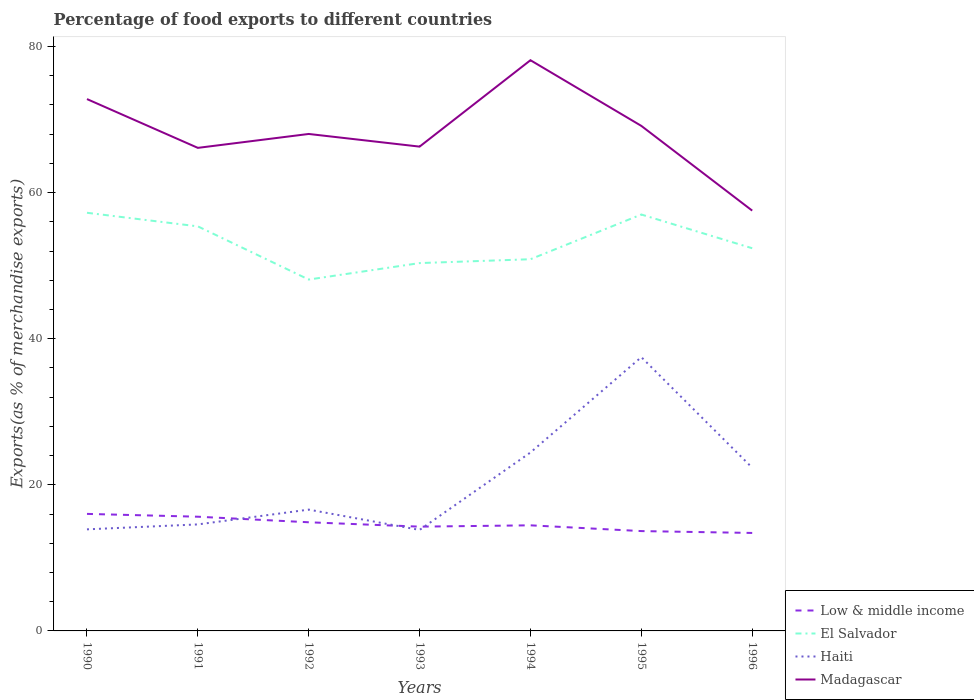How many different coloured lines are there?
Provide a succinct answer. 4. Across all years, what is the maximum percentage of exports to different countries in Madagascar?
Make the answer very short. 57.53. In which year was the percentage of exports to different countries in Haiti maximum?
Keep it short and to the point. 1993. What is the total percentage of exports to different countries in Madagascar in the graph?
Your response must be concise. 11.6. What is the difference between the highest and the second highest percentage of exports to different countries in Low & middle income?
Ensure brevity in your answer.  2.61. What is the difference between the highest and the lowest percentage of exports to different countries in Low & middle income?
Offer a very short reply. 3. Are the values on the major ticks of Y-axis written in scientific E-notation?
Give a very brief answer. No. Does the graph contain grids?
Offer a terse response. No. Where does the legend appear in the graph?
Provide a succinct answer. Bottom right. How many legend labels are there?
Ensure brevity in your answer.  4. How are the legend labels stacked?
Your answer should be very brief. Vertical. What is the title of the graph?
Provide a short and direct response. Percentage of food exports to different countries. What is the label or title of the Y-axis?
Offer a terse response. Exports(as % of merchandise exports). What is the Exports(as % of merchandise exports) of Low & middle income in 1990?
Your answer should be compact. 16.02. What is the Exports(as % of merchandise exports) of El Salvador in 1990?
Provide a succinct answer. 57.24. What is the Exports(as % of merchandise exports) in Haiti in 1990?
Keep it short and to the point. 13.9. What is the Exports(as % of merchandise exports) in Madagascar in 1990?
Keep it short and to the point. 72.8. What is the Exports(as % of merchandise exports) of Low & middle income in 1991?
Your answer should be very brief. 15.63. What is the Exports(as % of merchandise exports) in El Salvador in 1991?
Your answer should be very brief. 55.38. What is the Exports(as % of merchandise exports) in Haiti in 1991?
Ensure brevity in your answer.  14.58. What is the Exports(as % of merchandise exports) in Madagascar in 1991?
Your answer should be very brief. 66.12. What is the Exports(as % of merchandise exports) of Low & middle income in 1992?
Offer a very short reply. 14.87. What is the Exports(as % of merchandise exports) in El Salvador in 1992?
Your answer should be very brief. 48.1. What is the Exports(as % of merchandise exports) in Haiti in 1992?
Keep it short and to the point. 16.61. What is the Exports(as % of merchandise exports) in Madagascar in 1992?
Your response must be concise. 68.03. What is the Exports(as % of merchandise exports) of Low & middle income in 1993?
Offer a very short reply. 14.27. What is the Exports(as % of merchandise exports) in El Salvador in 1993?
Give a very brief answer. 50.35. What is the Exports(as % of merchandise exports) in Haiti in 1993?
Make the answer very short. 13.83. What is the Exports(as % of merchandise exports) of Madagascar in 1993?
Your answer should be compact. 66.29. What is the Exports(as % of merchandise exports) of Low & middle income in 1994?
Ensure brevity in your answer.  14.45. What is the Exports(as % of merchandise exports) in El Salvador in 1994?
Ensure brevity in your answer.  50.88. What is the Exports(as % of merchandise exports) of Haiti in 1994?
Your answer should be very brief. 24.42. What is the Exports(as % of merchandise exports) in Madagascar in 1994?
Your response must be concise. 78.12. What is the Exports(as % of merchandise exports) in Low & middle income in 1995?
Ensure brevity in your answer.  13.67. What is the Exports(as % of merchandise exports) of El Salvador in 1995?
Keep it short and to the point. 57. What is the Exports(as % of merchandise exports) in Haiti in 1995?
Make the answer very short. 37.48. What is the Exports(as % of merchandise exports) in Madagascar in 1995?
Provide a succinct answer. 69.13. What is the Exports(as % of merchandise exports) of Low & middle income in 1996?
Offer a very short reply. 13.41. What is the Exports(as % of merchandise exports) of El Salvador in 1996?
Your answer should be compact. 52.38. What is the Exports(as % of merchandise exports) in Haiti in 1996?
Provide a short and direct response. 22.34. What is the Exports(as % of merchandise exports) of Madagascar in 1996?
Give a very brief answer. 57.53. Across all years, what is the maximum Exports(as % of merchandise exports) in Low & middle income?
Give a very brief answer. 16.02. Across all years, what is the maximum Exports(as % of merchandise exports) of El Salvador?
Provide a succinct answer. 57.24. Across all years, what is the maximum Exports(as % of merchandise exports) of Haiti?
Offer a terse response. 37.48. Across all years, what is the maximum Exports(as % of merchandise exports) in Madagascar?
Ensure brevity in your answer.  78.12. Across all years, what is the minimum Exports(as % of merchandise exports) in Low & middle income?
Provide a succinct answer. 13.41. Across all years, what is the minimum Exports(as % of merchandise exports) of El Salvador?
Provide a succinct answer. 48.1. Across all years, what is the minimum Exports(as % of merchandise exports) in Haiti?
Keep it short and to the point. 13.83. Across all years, what is the minimum Exports(as % of merchandise exports) of Madagascar?
Ensure brevity in your answer.  57.53. What is the total Exports(as % of merchandise exports) in Low & middle income in the graph?
Give a very brief answer. 102.33. What is the total Exports(as % of merchandise exports) of El Salvador in the graph?
Make the answer very short. 371.32. What is the total Exports(as % of merchandise exports) in Haiti in the graph?
Your answer should be compact. 143.15. What is the total Exports(as % of merchandise exports) in Madagascar in the graph?
Ensure brevity in your answer.  478.03. What is the difference between the Exports(as % of merchandise exports) in Low & middle income in 1990 and that in 1991?
Ensure brevity in your answer.  0.39. What is the difference between the Exports(as % of merchandise exports) in El Salvador in 1990 and that in 1991?
Your answer should be compact. 1.86. What is the difference between the Exports(as % of merchandise exports) in Haiti in 1990 and that in 1991?
Keep it short and to the point. -0.68. What is the difference between the Exports(as % of merchandise exports) of Madagascar in 1990 and that in 1991?
Ensure brevity in your answer.  6.68. What is the difference between the Exports(as % of merchandise exports) in Low & middle income in 1990 and that in 1992?
Your answer should be compact. 1.15. What is the difference between the Exports(as % of merchandise exports) in El Salvador in 1990 and that in 1992?
Your answer should be very brief. 9.14. What is the difference between the Exports(as % of merchandise exports) in Haiti in 1990 and that in 1992?
Provide a short and direct response. -2.7. What is the difference between the Exports(as % of merchandise exports) in Madagascar in 1990 and that in 1992?
Offer a terse response. 4.78. What is the difference between the Exports(as % of merchandise exports) in Low & middle income in 1990 and that in 1993?
Give a very brief answer. 1.74. What is the difference between the Exports(as % of merchandise exports) in El Salvador in 1990 and that in 1993?
Your answer should be very brief. 6.89. What is the difference between the Exports(as % of merchandise exports) in Haiti in 1990 and that in 1993?
Make the answer very short. 0.08. What is the difference between the Exports(as % of merchandise exports) in Madagascar in 1990 and that in 1993?
Ensure brevity in your answer.  6.51. What is the difference between the Exports(as % of merchandise exports) in Low & middle income in 1990 and that in 1994?
Offer a very short reply. 1.56. What is the difference between the Exports(as % of merchandise exports) in El Salvador in 1990 and that in 1994?
Offer a terse response. 6.36. What is the difference between the Exports(as % of merchandise exports) of Haiti in 1990 and that in 1994?
Your answer should be very brief. -10.52. What is the difference between the Exports(as % of merchandise exports) of Madagascar in 1990 and that in 1994?
Your answer should be compact. -5.32. What is the difference between the Exports(as % of merchandise exports) in Low & middle income in 1990 and that in 1995?
Ensure brevity in your answer.  2.35. What is the difference between the Exports(as % of merchandise exports) of El Salvador in 1990 and that in 1995?
Make the answer very short. 0.24. What is the difference between the Exports(as % of merchandise exports) of Haiti in 1990 and that in 1995?
Your answer should be very brief. -23.57. What is the difference between the Exports(as % of merchandise exports) of Madagascar in 1990 and that in 1995?
Provide a succinct answer. 3.67. What is the difference between the Exports(as % of merchandise exports) in Low & middle income in 1990 and that in 1996?
Provide a short and direct response. 2.61. What is the difference between the Exports(as % of merchandise exports) of El Salvador in 1990 and that in 1996?
Make the answer very short. 4.85. What is the difference between the Exports(as % of merchandise exports) of Haiti in 1990 and that in 1996?
Provide a short and direct response. -8.43. What is the difference between the Exports(as % of merchandise exports) of Madagascar in 1990 and that in 1996?
Keep it short and to the point. 15.27. What is the difference between the Exports(as % of merchandise exports) in Low & middle income in 1991 and that in 1992?
Your answer should be compact. 0.76. What is the difference between the Exports(as % of merchandise exports) in El Salvador in 1991 and that in 1992?
Keep it short and to the point. 7.28. What is the difference between the Exports(as % of merchandise exports) in Haiti in 1991 and that in 1992?
Your answer should be compact. -2.03. What is the difference between the Exports(as % of merchandise exports) in Madagascar in 1991 and that in 1992?
Provide a succinct answer. -1.9. What is the difference between the Exports(as % of merchandise exports) in Low & middle income in 1991 and that in 1993?
Your response must be concise. 1.36. What is the difference between the Exports(as % of merchandise exports) in El Salvador in 1991 and that in 1993?
Offer a terse response. 5.03. What is the difference between the Exports(as % of merchandise exports) in Haiti in 1991 and that in 1993?
Ensure brevity in your answer.  0.75. What is the difference between the Exports(as % of merchandise exports) in Madagascar in 1991 and that in 1993?
Ensure brevity in your answer.  -0.17. What is the difference between the Exports(as % of merchandise exports) in Low & middle income in 1991 and that in 1994?
Provide a short and direct response. 1.18. What is the difference between the Exports(as % of merchandise exports) in El Salvador in 1991 and that in 1994?
Your answer should be very brief. 4.5. What is the difference between the Exports(as % of merchandise exports) in Haiti in 1991 and that in 1994?
Provide a short and direct response. -9.84. What is the difference between the Exports(as % of merchandise exports) of Madagascar in 1991 and that in 1994?
Provide a succinct answer. -12. What is the difference between the Exports(as % of merchandise exports) in Low & middle income in 1991 and that in 1995?
Ensure brevity in your answer.  1.97. What is the difference between the Exports(as % of merchandise exports) of El Salvador in 1991 and that in 1995?
Make the answer very short. -1.62. What is the difference between the Exports(as % of merchandise exports) in Haiti in 1991 and that in 1995?
Ensure brevity in your answer.  -22.9. What is the difference between the Exports(as % of merchandise exports) of Madagascar in 1991 and that in 1995?
Your response must be concise. -3.01. What is the difference between the Exports(as % of merchandise exports) in Low & middle income in 1991 and that in 1996?
Offer a terse response. 2.22. What is the difference between the Exports(as % of merchandise exports) in El Salvador in 1991 and that in 1996?
Give a very brief answer. 2.99. What is the difference between the Exports(as % of merchandise exports) of Haiti in 1991 and that in 1996?
Your answer should be very brief. -7.76. What is the difference between the Exports(as % of merchandise exports) of Madagascar in 1991 and that in 1996?
Keep it short and to the point. 8.59. What is the difference between the Exports(as % of merchandise exports) of Low & middle income in 1992 and that in 1993?
Your answer should be compact. 0.6. What is the difference between the Exports(as % of merchandise exports) in El Salvador in 1992 and that in 1993?
Offer a very short reply. -2.25. What is the difference between the Exports(as % of merchandise exports) of Haiti in 1992 and that in 1993?
Offer a very short reply. 2.78. What is the difference between the Exports(as % of merchandise exports) of Madagascar in 1992 and that in 1993?
Ensure brevity in your answer.  1.73. What is the difference between the Exports(as % of merchandise exports) of Low & middle income in 1992 and that in 1994?
Provide a short and direct response. 0.42. What is the difference between the Exports(as % of merchandise exports) in El Salvador in 1992 and that in 1994?
Provide a succinct answer. -2.78. What is the difference between the Exports(as % of merchandise exports) in Haiti in 1992 and that in 1994?
Your response must be concise. -7.82. What is the difference between the Exports(as % of merchandise exports) in Madagascar in 1992 and that in 1994?
Provide a succinct answer. -10.09. What is the difference between the Exports(as % of merchandise exports) of Low & middle income in 1992 and that in 1995?
Make the answer very short. 1.21. What is the difference between the Exports(as % of merchandise exports) in El Salvador in 1992 and that in 1995?
Give a very brief answer. -8.9. What is the difference between the Exports(as % of merchandise exports) of Haiti in 1992 and that in 1995?
Ensure brevity in your answer.  -20.87. What is the difference between the Exports(as % of merchandise exports) in Madagascar in 1992 and that in 1995?
Provide a succinct answer. -1.1. What is the difference between the Exports(as % of merchandise exports) of Low & middle income in 1992 and that in 1996?
Provide a succinct answer. 1.46. What is the difference between the Exports(as % of merchandise exports) in El Salvador in 1992 and that in 1996?
Keep it short and to the point. -4.29. What is the difference between the Exports(as % of merchandise exports) of Haiti in 1992 and that in 1996?
Ensure brevity in your answer.  -5.73. What is the difference between the Exports(as % of merchandise exports) of Madagascar in 1992 and that in 1996?
Make the answer very short. 10.49. What is the difference between the Exports(as % of merchandise exports) in Low & middle income in 1993 and that in 1994?
Offer a terse response. -0.18. What is the difference between the Exports(as % of merchandise exports) in El Salvador in 1993 and that in 1994?
Your answer should be compact. -0.53. What is the difference between the Exports(as % of merchandise exports) of Haiti in 1993 and that in 1994?
Provide a succinct answer. -10.6. What is the difference between the Exports(as % of merchandise exports) of Madagascar in 1993 and that in 1994?
Make the answer very short. -11.83. What is the difference between the Exports(as % of merchandise exports) of Low & middle income in 1993 and that in 1995?
Your answer should be compact. 0.61. What is the difference between the Exports(as % of merchandise exports) of El Salvador in 1993 and that in 1995?
Ensure brevity in your answer.  -6.65. What is the difference between the Exports(as % of merchandise exports) in Haiti in 1993 and that in 1995?
Provide a succinct answer. -23.65. What is the difference between the Exports(as % of merchandise exports) of Madagascar in 1993 and that in 1995?
Your answer should be very brief. -2.84. What is the difference between the Exports(as % of merchandise exports) in Low & middle income in 1993 and that in 1996?
Make the answer very short. 0.86. What is the difference between the Exports(as % of merchandise exports) in El Salvador in 1993 and that in 1996?
Offer a very short reply. -2.03. What is the difference between the Exports(as % of merchandise exports) of Haiti in 1993 and that in 1996?
Keep it short and to the point. -8.51. What is the difference between the Exports(as % of merchandise exports) of Madagascar in 1993 and that in 1996?
Provide a short and direct response. 8.76. What is the difference between the Exports(as % of merchandise exports) in Low & middle income in 1994 and that in 1995?
Your answer should be very brief. 0.79. What is the difference between the Exports(as % of merchandise exports) of El Salvador in 1994 and that in 1995?
Make the answer very short. -6.12. What is the difference between the Exports(as % of merchandise exports) of Haiti in 1994 and that in 1995?
Ensure brevity in your answer.  -13.05. What is the difference between the Exports(as % of merchandise exports) in Madagascar in 1994 and that in 1995?
Offer a terse response. 8.99. What is the difference between the Exports(as % of merchandise exports) in Low & middle income in 1994 and that in 1996?
Make the answer very short. 1.04. What is the difference between the Exports(as % of merchandise exports) in El Salvador in 1994 and that in 1996?
Provide a short and direct response. -1.5. What is the difference between the Exports(as % of merchandise exports) in Haiti in 1994 and that in 1996?
Your answer should be very brief. 2.09. What is the difference between the Exports(as % of merchandise exports) of Madagascar in 1994 and that in 1996?
Your answer should be very brief. 20.59. What is the difference between the Exports(as % of merchandise exports) in Low & middle income in 1995 and that in 1996?
Provide a short and direct response. 0.26. What is the difference between the Exports(as % of merchandise exports) of El Salvador in 1995 and that in 1996?
Your answer should be very brief. 4.62. What is the difference between the Exports(as % of merchandise exports) in Haiti in 1995 and that in 1996?
Offer a very short reply. 15.14. What is the difference between the Exports(as % of merchandise exports) of Madagascar in 1995 and that in 1996?
Give a very brief answer. 11.6. What is the difference between the Exports(as % of merchandise exports) of Low & middle income in 1990 and the Exports(as % of merchandise exports) of El Salvador in 1991?
Your answer should be very brief. -39.36. What is the difference between the Exports(as % of merchandise exports) in Low & middle income in 1990 and the Exports(as % of merchandise exports) in Haiti in 1991?
Offer a very short reply. 1.44. What is the difference between the Exports(as % of merchandise exports) in Low & middle income in 1990 and the Exports(as % of merchandise exports) in Madagascar in 1991?
Offer a terse response. -50.1. What is the difference between the Exports(as % of merchandise exports) in El Salvador in 1990 and the Exports(as % of merchandise exports) in Haiti in 1991?
Offer a terse response. 42.66. What is the difference between the Exports(as % of merchandise exports) in El Salvador in 1990 and the Exports(as % of merchandise exports) in Madagascar in 1991?
Your answer should be compact. -8.89. What is the difference between the Exports(as % of merchandise exports) of Haiti in 1990 and the Exports(as % of merchandise exports) of Madagascar in 1991?
Offer a very short reply. -52.22. What is the difference between the Exports(as % of merchandise exports) of Low & middle income in 1990 and the Exports(as % of merchandise exports) of El Salvador in 1992?
Ensure brevity in your answer.  -32.08. What is the difference between the Exports(as % of merchandise exports) of Low & middle income in 1990 and the Exports(as % of merchandise exports) of Haiti in 1992?
Your response must be concise. -0.59. What is the difference between the Exports(as % of merchandise exports) in Low & middle income in 1990 and the Exports(as % of merchandise exports) in Madagascar in 1992?
Ensure brevity in your answer.  -52.01. What is the difference between the Exports(as % of merchandise exports) of El Salvador in 1990 and the Exports(as % of merchandise exports) of Haiti in 1992?
Offer a terse response. 40.63. What is the difference between the Exports(as % of merchandise exports) of El Salvador in 1990 and the Exports(as % of merchandise exports) of Madagascar in 1992?
Ensure brevity in your answer.  -10.79. What is the difference between the Exports(as % of merchandise exports) in Haiti in 1990 and the Exports(as % of merchandise exports) in Madagascar in 1992?
Give a very brief answer. -54.12. What is the difference between the Exports(as % of merchandise exports) in Low & middle income in 1990 and the Exports(as % of merchandise exports) in El Salvador in 1993?
Keep it short and to the point. -34.33. What is the difference between the Exports(as % of merchandise exports) of Low & middle income in 1990 and the Exports(as % of merchandise exports) of Haiti in 1993?
Your response must be concise. 2.19. What is the difference between the Exports(as % of merchandise exports) of Low & middle income in 1990 and the Exports(as % of merchandise exports) of Madagascar in 1993?
Offer a terse response. -50.27. What is the difference between the Exports(as % of merchandise exports) in El Salvador in 1990 and the Exports(as % of merchandise exports) in Haiti in 1993?
Provide a succinct answer. 43.41. What is the difference between the Exports(as % of merchandise exports) in El Salvador in 1990 and the Exports(as % of merchandise exports) in Madagascar in 1993?
Your response must be concise. -9.06. What is the difference between the Exports(as % of merchandise exports) in Haiti in 1990 and the Exports(as % of merchandise exports) in Madagascar in 1993?
Make the answer very short. -52.39. What is the difference between the Exports(as % of merchandise exports) in Low & middle income in 1990 and the Exports(as % of merchandise exports) in El Salvador in 1994?
Your response must be concise. -34.86. What is the difference between the Exports(as % of merchandise exports) in Low & middle income in 1990 and the Exports(as % of merchandise exports) in Haiti in 1994?
Make the answer very short. -8.4. What is the difference between the Exports(as % of merchandise exports) in Low & middle income in 1990 and the Exports(as % of merchandise exports) in Madagascar in 1994?
Give a very brief answer. -62.1. What is the difference between the Exports(as % of merchandise exports) of El Salvador in 1990 and the Exports(as % of merchandise exports) of Haiti in 1994?
Your answer should be compact. 32.81. What is the difference between the Exports(as % of merchandise exports) in El Salvador in 1990 and the Exports(as % of merchandise exports) in Madagascar in 1994?
Offer a very short reply. -20.88. What is the difference between the Exports(as % of merchandise exports) in Haiti in 1990 and the Exports(as % of merchandise exports) in Madagascar in 1994?
Your answer should be very brief. -64.22. What is the difference between the Exports(as % of merchandise exports) of Low & middle income in 1990 and the Exports(as % of merchandise exports) of El Salvador in 1995?
Keep it short and to the point. -40.98. What is the difference between the Exports(as % of merchandise exports) of Low & middle income in 1990 and the Exports(as % of merchandise exports) of Haiti in 1995?
Provide a short and direct response. -21.46. What is the difference between the Exports(as % of merchandise exports) in Low & middle income in 1990 and the Exports(as % of merchandise exports) in Madagascar in 1995?
Provide a short and direct response. -53.11. What is the difference between the Exports(as % of merchandise exports) in El Salvador in 1990 and the Exports(as % of merchandise exports) in Haiti in 1995?
Keep it short and to the point. 19.76. What is the difference between the Exports(as % of merchandise exports) in El Salvador in 1990 and the Exports(as % of merchandise exports) in Madagascar in 1995?
Your answer should be very brief. -11.89. What is the difference between the Exports(as % of merchandise exports) in Haiti in 1990 and the Exports(as % of merchandise exports) in Madagascar in 1995?
Make the answer very short. -55.23. What is the difference between the Exports(as % of merchandise exports) of Low & middle income in 1990 and the Exports(as % of merchandise exports) of El Salvador in 1996?
Keep it short and to the point. -36.36. What is the difference between the Exports(as % of merchandise exports) of Low & middle income in 1990 and the Exports(as % of merchandise exports) of Haiti in 1996?
Provide a succinct answer. -6.32. What is the difference between the Exports(as % of merchandise exports) of Low & middle income in 1990 and the Exports(as % of merchandise exports) of Madagascar in 1996?
Offer a terse response. -41.51. What is the difference between the Exports(as % of merchandise exports) in El Salvador in 1990 and the Exports(as % of merchandise exports) in Haiti in 1996?
Offer a very short reply. 34.9. What is the difference between the Exports(as % of merchandise exports) of El Salvador in 1990 and the Exports(as % of merchandise exports) of Madagascar in 1996?
Give a very brief answer. -0.3. What is the difference between the Exports(as % of merchandise exports) in Haiti in 1990 and the Exports(as % of merchandise exports) in Madagascar in 1996?
Provide a short and direct response. -43.63. What is the difference between the Exports(as % of merchandise exports) of Low & middle income in 1991 and the Exports(as % of merchandise exports) of El Salvador in 1992?
Provide a succinct answer. -32.46. What is the difference between the Exports(as % of merchandise exports) in Low & middle income in 1991 and the Exports(as % of merchandise exports) in Haiti in 1992?
Provide a short and direct response. -0.97. What is the difference between the Exports(as % of merchandise exports) in Low & middle income in 1991 and the Exports(as % of merchandise exports) in Madagascar in 1992?
Provide a succinct answer. -52.39. What is the difference between the Exports(as % of merchandise exports) of El Salvador in 1991 and the Exports(as % of merchandise exports) of Haiti in 1992?
Make the answer very short. 38.77. What is the difference between the Exports(as % of merchandise exports) of El Salvador in 1991 and the Exports(as % of merchandise exports) of Madagascar in 1992?
Your answer should be very brief. -12.65. What is the difference between the Exports(as % of merchandise exports) of Haiti in 1991 and the Exports(as % of merchandise exports) of Madagascar in 1992?
Provide a short and direct response. -53.45. What is the difference between the Exports(as % of merchandise exports) in Low & middle income in 1991 and the Exports(as % of merchandise exports) in El Salvador in 1993?
Give a very brief answer. -34.72. What is the difference between the Exports(as % of merchandise exports) in Low & middle income in 1991 and the Exports(as % of merchandise exports) in Haiti in 1993?
Offer a very short reply. 1.81. What is the difference between the Exports(as % of merchandise exports) of Low & middle income in 1991 and the Exports(as % of merchandise exports) of Madagascar in 1993?
Your response must be concise. -50.66. What is the difference between the Exports(as % of merchandise exports) in El Salvador in 1991 and the Exports(as % of merchandise exports) in Haiti in 1993?
Make the answer very short. 41.55. What is the difference between the Exports(as % of merchandise exports) in El Salvador in 1991 and the Exports(as % of merchandise exports) in Madagascar in 1993?
Your answer should be very brief. -10.92. What is the difference between the Exports(as % of merchandise exports) in Haiti in 1991 and the Exports(as % of merchandise exports) in Madagascar in 1993?
Your answer should be compact. -51.71. What is the difference between the Exports(as % of merchandise exports) in Low & middle income in 1991 and the Exports(as % of merchandise exports) in El Salvador in 1994?
Your answer should be very brief. -35.24. What is the difference between the Exports(as % of merchandise exports) of Low & middle income in 1991 and the Exports(as % of merchandise exports) of Haiti in 1994?
Give a very brief answer. -8.79. What is the difference between the Exports(as % of merchandise exports) of Low & middle income in 1991 and the Exports(as % of merchandise exports) of Madagascar in 1994?
Give a very brief answer. -62.49. What is the difference between the Exports(as % of merchandise exports) in El Salvador in 1991 and the Exports(as % of merchandise exports) in Haiti in 1994?
Offer a very short reply. 30.95. What is the difference between the Exports(as % of merchandise exports) in El Salvador in 1991 and the Exports(as % of merchandise exports) in Madagascar in 1994?
Your answer should be compact. -22.74. What is the difference between the Exports(as % of merchandise exports) in Haiti in 1991 and the Exports(as % of merchandise exports) in Madagascar in 1994?
Keep it short and to the point. -63.54. What is the difference between the Exports(as % of merchandise exports) of Low & middle income in 1991 and the Exports(as % of merchandise exports) of El Salvador in 1995?
Your response must be concise. -41.37. What is the difference between the Exports(as % of merchandise exports) of Low & middle income in 1991 and the Exports(as % of merchandise exports) of Haiti in 1995?
Provide a short and direct response. -21.84. What is the difference between the Exports(as % of merchandise exports) in Low & middle income in 1991 and the Exports(as % of merchandise exports) in Madagascar in 1995?
Offer a terse response. -53.5. What is the difference between the Exports(as % of merchandise exports) in El Salvador in 1991 and the Exports(as % of merchandise exports) in Haiti in 1995?
Keep it short and to the point. 17.9. What is the difference between the Exports(as % of merchandise exports) of El Salvador in 1991 and the Exports(as % of merchandise exports) of Madagascar in 1995?
Keep it short and to the point. -13.75. What is the difference between the Exports(as % of merchandise exports) of Haiti in 1991 and the Exports(as % of merchandise exports) of Madagascar in 1995?
Offer a terse response. -54.55. What is the difference between the Exports(as % of merchandise exports) of Low & middle income in 1991 and the Exports(as % of merchandise exports) of El Salvador in 1996?
Keep it short and to the point. -36.75. What is the difference between the Exports(as % of merchandise exports) of Low & middle income in 1991 and the Exports(as % of merchandise exports) of Haiti in 1996?
Your answer should be very brief. -6.7. What is the difference between the Exports(as % of merchandise exports) in Low & middle income in 1991 and the Exports(as % of merchandise exports) in Madagascar in 1996?
Provide a succinct answer. -41.9. What is the difference between the Exports(as % of merchandise exports) of El Salvador in 1991 and the Exports(as % of merchandise exports) of Haiti in 1996?
Keep it short and to the point. 33.04. What is the difference between the Exports(as % of merchandise exports) of El Salvador in 1991 and the Exports(as % of merchandise exports) of Madagascar in 1996?
Provide a short and direct response. -2.16. What is the difference between the Exports(as % of merchandise exports) of Haiti in 1991 and the Exports(as % of merchandise exports) of Madagascar in 1996?
Your answer should be compact. -42.95. What is the difference between the Exports(as % of merchandise exports) in Low & middle income in 1992 and the Exports(as % of merchandise exports) in El Salvador in 1993?
Your answer should be compact. -35.48. What is the difference between the Exports(as % of merchandise exports) of Low & middle income in 1992 and the Exports(as % of merchandise exports) of Haiti in 1993?
Your response must be concise. 1.05. What is the difference between the Exports(as % of merchandise exports) of Low & middle income in 1992 and the Exports(as % of merchandise exports) of Madagascar in 1993?
Make the answer very short. -51.42. What is the difference between the Exports(as % of merchandise exports) of El Salvador in 1992 and the Exports(as % of merchandise exports) of Haiti in 1993?
Offer a very short reply. 34.27. What is the difference between the Exports(as % of merchandise exports) of El Salvador in 1992 and the Exports(as % of merchandise exports) of Madagascar in 1993?
Keep it short and to the point. -18.2. What is the difference between the Exports(as % of merchandise exports) in Haiti in 1992 and the Exports(as % of merchandise exports) in Madagascar in 1993?
Offer a terse response. -49.69. What is the difference between the Exports(as % of merchandise exports) in Low & middle income in 1992 and the Exports(as % of merchandise exports) in El Salvador in 1994?
Offer a very short reply. -36.01. What is the difference between the Exports(as % of merchandise exports) in Low & middle income in 1992 and the Exports(as % of merchandise exports) in Haiti in 1994?
Provide a succinct answer. -9.55. What is the difference between the Exports(as % of merchandise exports) in Low & middle income in 1992 and the Exports(as % of merchandise exports) in Madagascar in 1994?
Offer a very short reply. -63.25. What is the difference between the Exports(as % of merchandise exports) in El Salvador in 1992 and the Exports(as % of merchandise exports) in Haiti in 1994?
Offer a terse response. 23.67. What is the difference between the Exports(as % of merchandise exports) in El Salvador in 1992 and the Exports(as % of merchandise exports) in Madagascar in 1994?
Ensure brevity in your answer.  -30.02. What is the difference between the Exports(as % of merchandise exports) in Haiti in 1992 and the Exports(as % of merchandise exports) in Madagascar in 1994?
Offer a very short reply. -61.52. What is the difference between the Exports(as % of merchandise exports) in Low & middle income in 1992 and the Exports(as % of merchandise exports) in El Salvador in 1995?
Keep it short and to the point. -42.13. What is the difference between the Exports(as % of merchandise exports) in Low & middle income in 1992 and the Exports(as % of merchandise exports) in Haiti in 1995?
Offer a terse response. -22.6. What is the difference between the Exports(as % of merchandise exports) in Low & middle income in 1992 and the Exports(as % of merchandise exports) in Madagascar in 1995?
Your answer should be compact. -54.26. What is the difference between the Exports(as % of merchandise exports) of El Salvador in 1992 and the Exports(as % of merchandise exports) of Haiti in 1995?
Your answer should be very brief. 10.62. What is the difference between the Exports(as % of merchandise exports) in El Salvador in 1992 and the Exports(as % of merchandise exports) in Madagascar in 1995?
Give a very brief answer. -21.03. What is the difference between the Exports(as % of merchandise exports) of Haiti in 1992 and the Exports(as % of merchandise exports) of Madagascar in 1995?
Give a very brief answer. -52.52. What is the difference between the Exports(as % of merchandise exports) in Low & middle income in 1992 and the Exports(as % of merchandise exports) in El Salvador in 1996?
Keep it short and to the point. -37.51. What is the difference between the Exports(as % of merchandise exports) in Low & middle income in 1992 and the Exports(as % of merchandise exports) in Haiti in 1996?
Keep it short and to the point. -7.46. What is the difference between the Exports(as % of merchandise exports) of Low & middle income in 1992 and the Exports(as % of merchandise exports) of Madagascar in 1996?
Make the answer very short. -42.66. What is the difference between the Exports(as % of merchandise exports) of El Salvador in 1992 and the Exports(as % of merchandise exports) of Haiti in 1996?
Your response must be concise. 25.76. What is the difference between the Exports(as % of merchandise exports) in El Salvador in 1992 and the Exports(as % of merchandise exports) in Madagascar in 1996?
Provide a short and direct response. -9.44. What is the difference between the Exports(as % of merchandise exports) of Haiti in 1992 and the Exports(as % of merchandise exports) of Madagascar in 1996?
Your answer should be very brief. -40.93. What is the difference between the Exports(as % of merchandise exports) of Low & middle income in 1993 and the Exports(as % of merchandise exports) of El Salvador in 1994?
Provide a short and direct response. -36.6. What is the difference between the Exports(as % of merchandise exports) in Low & middle income in 1993 and the Exports(as % of merchandise exports) in Haiti in 1994?
Offer a terse response. -10.15. What is the difference between the Exports(as % of merchandise exports) of Low & middle income in 1993 and the Exports(as % of merchandise exports) of Madagascar in 1994?
Your answer should be compact. -63.85. What is the difference between the Exports(as % of merchandise exports) in El Salvador in 1993 and the Exports(as % of merchandise exports) in Haiti in 1994?
Offer a very short reply. 25.93. What is the difference between the Exports(as % of merchandise exports) of El Salvador in 1993 and the Exports(as % of merchandise exports) of Madagascar in 1994?
Keep it short and to the point. -27.77. What is the difference between the Exports(as % of merchandise exports) in Haiti in 1993 and the Exports(as % of merchandise exports) in Madagascar in 1994?
Offer a terse response. -64.29. What is the difference between the Exports(as % of merchandise exports) of Low & middle income in 1993 and the Exports(as % of merchandise exports) of El Salvador in 1995?
Make the answer very short. -42.72. What is the difference between the Exports(as % of merchandise exports) of Low & middle income in 1993 and the Exports(as % of merchandise exports) of Haiti in 1995?
Ensure brevity in your answer.  -23.2. What is the difference between the Exports(as % of merchandise exports) in Low & middle income in 1993 and the Exports(as % of merchandise exports) in Madagascar in 1995?
Offer a terse response. -54.86. What is the difference between the Exports(as % of merchandise exports) of El Salvador in 1993 and the Exports(as % of merchandise exports) of Haiti in 1995?
Your answer should be compact. 12.88. What is the difference between the Exports(as % of merchandise exports) of El Salvador in 1993 and the Exports(as % of merchandise exports) of Madagascar in 1995?
Keep it short and to the point. -18.78. What is the difference between the Exports(as % of merchandise exports) in Haiti in 1993 and the Exports(as % of merchandise exports) in Madagascar in 1995?
Your response must be concise. -55.3. What is the difference between the Exports(as % of merchandise exports) in Low & middle income in 1993 and the Exports(as % of merchandise exports) in El Salvador in 1996?
Keep it short and to the point. -38.11. What is the difference between the Exports(as % of merchandise exports) in Low & middle income in 1993 and the Exports(as % of merchandise exports) in Haiti in 1996?
Ensure brevity in your answer.  -8.06. What is the difference between the Exports(as % of merchandise exports) in Low & middle income in 1993 and the Exports(as % of merchandise exports) in Madagascar in 1996?
Your answer should be compact. -43.26. What is the difference between the Exports(as % of merchandise exports) in El Salvador in 1993 and the Exports(as % of merchandise exports) in Haiti in 1996?
Provide a succinct answer. 28.01. What is the difference between the Exports(as % of merchandise exports) of El Salvador in 1993 and the Exports(as % of merchandise exports) of Madagascar in 1996?
Keep it short and to the point. -7.18. What is the difference between the Exports(as % of merchandise exports) of Haiti in 1993 and the Exports(as % of merchandise exports) of Madagascar in 1996?
Your answer should be compact. -43.71. What is the difference between the Exports(as % of merchandise exports) in Low & middle income in 1994 and the Exports(as % of merchandise exports) in El Salvador in 1995?
Your answer should be compact. -42.55. What is the difference between the Exports(as % of merchandise exports) in Low & middle income in 1994 and the Exports(as % of merchandise exports) in Haiti in 1995?
Provide a succinct answer. -23.02. What is the difference between the Exports(as % of merchandise exports) in Low & middle income in 1994 and the Exports(as % of merchandise exports) in Madagascar in 1995?
Keep it short and to the point. -54.68. What is the difference between the Exports(as % of merchandise exports) of El Salvador in 1994 and the Exports(as % of merchandise exports) of Haiti in 1995?
Offer a terse response. 13.4. What is the difference between the Exports(as % of merchandise exports) of El Salvador in 1994 and the Exports(as % of merchandise exports) of Madagascar in 1995?
Give a very brief answer. -18.25. What is the difference between the Exports(as % of merchandise exports) in Haiti in 1994 and the Exports(as % of merchandise exports) in Madagascar in 1995?
Provide a succinct answer. -44.71. What is the difference between the Exports(as % of merchandise exports) of Low & middle income in 1994 and the Exports(as % of merchandise exports) of El Salvador in 1996?
Ensure brevity in your answer.  -37.93. What is the difference between the Exports(as % of merchandise exports) in Low & middle income in 1994 and the Exports(as % of merchandise exports) in Haiti in 1996?
Keep it short and to the point. -7.88. What is the difference between the Exports(as % of merchandise exports) of Low & middle income in 1994 and the Exports(as % of merchandise exports) of Madagascar in 1996?
Ensure brevity in your answer.  -43.08. What is the difference between the Exports(as % of merchandise exports) in El Salvador in 1994 and the Exports(as % of merchandise exports) in Haiti in 1996?
Your answer should be very brief. 28.54. What is the difference between the Exports(as % of merchandise exports) in El Salvador in 1994 and the Exports(as % of merchandise exports) in Madagascar in 1996?
Keep it short and to the point. -6.65. What is the difference between the Exports(as % of merchandise exports) of Haiti in 1994 and the Exports(as % of merchandise exports) of Madagascar in 1996?
Provide a succinct answer. -33.11. What is the difference between the Exports(as % of merchandise exports) in Low & middle income in 1995 and the Exports(as % of merchandise exports) in El Salvador in 1996?
Provide a short and direct response. -38.72. What is the difference between the Exports(as % of merchandise exports) in Low & middle income in 1995 and the Exports(as % of merchandise exports) in Haiti in 1996?
Your answer should be very brief. -8.67. What is the difference between the Exports(as % of merchandise exports) of Low & middle income in 1995 and the Exports(as % of merchandise exports) of Madagascar in 1996?
Keep it short and to the point. -43.87. What is the difference between the Exports(as % of merchandise exports) in El Salvador in 1995 and the Exports(as % of merchandise exports) in Haiti in 1996?
Provide a succinct answer. 34.66. What is the difference between the Exports(as % of merchandise exports) of El Salvador in 1995 and the Exports(as % of merchandise exports) of Madagascar in 1996?
Give a very brief answer. -0.53. What is the difference between the Exports(as % of merchandise exports) in Haiti in 1995 and the Exports(as % of merchandise exports) in Madagascar in 1996?
Provide a short and direct response. -20.06. What is the average Exports(as % of merchandise exports) in Low & middle income per year?
Your answer should be very brief. 14.62. What is the average Exports(as % of merchandise exports) of El Salvador per year?
Make the answer very short. 53.05. What is the average Exports(as % of merchandise exports) in Haiti per year?
Keep it short and to the point. 20.45. What is the average Exports(as % of merchandise exports) in Madagascar per year?
Keep it short and to the point. 68.29. In the year 1990, what is the difference between the Exports(as % of merchandise exports) in Low & middle income and Exports(as % of merchandise exports) in El Salvador?
Keep it short and to the point. -41.22. In the year 1990, what is the difference between the Exports(as % of merchandise exports) of Low & middle income and Exports(as % of merchandise exports) of Haiti?
Give a very brief answer. 2.11. In the year 1990, what is the difference between the Exports(as % of merchandise exports) in Low & middle income and Exports(as % of merchandise exports) in Madagascar?
Your answer should be very brief. -56.78. In the year 1990, what is the difference between the Exports(as % of merchandise exports) in El Salvador and Exports(as % of merchandise exports) in Haiti?
Provide a short and direct response. 43.33. In the year 1990, what is the difference between the Exports(as % of merchandise exports) in El Salvador and Exports(as % of merchandise exports) in Madagascar?
Your response must be concise. -15.56. In the year 1990, what is the difference between the Exports(as % of merchandise exports) of Haiti and Exports(as % of merchandise exports) of Madagascar?
Make the answer very short. -58.9. In the year 1991, what is the difference between the Exports(as % of merchandise exports) in Low & middle income and Exports(as % of merchandise exports) in El Salvador?
Keep it short and to the point. -39.74. In the year 1991, what is the difference between the Exports(as % of merchandise exports) of Low & middle income and Exports(as % of merchandise exports) of Haiti?
Ensure brevity in your answer.  1.05. In the year 1991, what is the difference between the Exports(as % of merchandise exports) of Low & middle income and Exports(as % of merchandise exports) of Madagascar?
Offer a very short reply. -50.49. In the year 1991, what is the difference between the Exports(as % of merchandise exports) in El Salvador and Exports(as % of merchandise exports) in Haiti?
Offer a terse response. 40.8. In the year 1991, what is the difference between the Exports(as % of merchandise exports) in El Salvador and Exports(as % of merchandise exports) in Madagascar?
Offer a very short reply. -10.75. In the year 1991, what is the difference between the Exports(as % of merchandise exports) of Haiti and Exports(as % of merchandise exports) of Madagascar?
Your response must be concise. -51.54. In the year 1992, what is the difference between the Exports(as % of merchandise exports) in Low & middle income and Exports(as % of merchandise exports) in El Salvador?
Offer a terse response. -33.22. In the year 1992, what is the difference between the Exports(as % of merchandise exports) of Low & middle income and Exports(as % of merchandise exports) of Haiti?
Provide a succinct answer. -1.73. In the year 1992, what is the difference between the Exports(as % of merchandise exports) of Low & middle income and Exports(as % of merchandise exports) of Madagascar?
Offer a terse response. -53.15. In the year 1992, what is the difference between the Exports(as % of merchandise exports) of El Salvador and Exports(as % of merchandise exports) of Haiti?
Give a very brief answer. 31.49. In the year 1992, what is the difference between the Exports(as % of merchandise exports) of El Salvador and Exports(as % of merchandise exports) of Madagascar?
Provide a short and direct response. -19.93. In the year 1992, what is the difference between the Exports(as % of merchandise exports) of Haiti and Exports(as % of merchandise exports) of Madagascar?
Provide a succinct answer. -51.42. In the year 1993, what is the difference between the Exports(as % of merchandise exports) of Low & middle income and Exports(as % of merchandise exports) of El Salvador?
Your response must be concise. -36.08. In the year 1993, what is the difference between the Exports(as % of merchandise exports) of Low & middle income and Exports(as % of merchandise exports) of Haiti?
Your response must be concise. 0.45. In the year 1993, what is the difference between the Exports(as % of merchandise exports) of Low & middle income and Exports(as % of merchandise exports) of Madagascar?
Make the answer very short. -52.02. In the year 1993, what is the difference between the Exports(as % of merchandise exports) in El Salvador and Exports(as % of merchandise exports) in Haiti?
Offer a terse response. 36.52. In the year 1993, what is the difference between the Exports(as % of merchandise exports) in El Salvador and Exports(as % of merchandise exports) in Madagascar?
Provide a short and direct response. -15.94. In the year 1993, what is the difference between the Exports(as % of merchandise exports) in Haiti and Exports(as % of merchandise exports) in Madagascar?
Ensure brevity in your answer.  -52.47. In the year 1994, what is the difference between the Exports(as % of merchandise exports) of Low & middle income and Exports(as % of merchandise exports) of El Salvador?
Ensure brevity in your answer.  -36.42. In the year 1994, what is the difference between the Exports(as % of merchandise exports) in Low & middle income and Exports(as % of merchandise exports) in Haiti?
Offer a terse response. -9.97. In the year 1994, what is the difference between the Exports(as % of merchandise exports) in Low & middle income and Exports(as % of merchandise exports) in Madagascar?
Your answer should be compact. -63.67. In the year 1994, what is the difference between the Exports(as % of merchandise exports) in El Salvador and Exports(as % of merchandise exports) in Haiti?
Provide a short and direct response. 26.45. In the year 1994, what is the difference between the Exports(as % of merchandise exports) in El Salvador and Exports(as % of merchandise exports) in Madagascar?
Make the answer very short. -27.24. In the year 1994, what is the difference between the Exports(as % of merchandise exports) in Haiti and Exports(as % of merchandise exports) in Madagascar?
Provide a succinct answer. -53.7. In the year 1995, what is the difference between the Exports(as % of merchandise exports) in Low & middle income and Exports(as % of merchandise exports) in El Salvador?
Your answer should be compact. -43.33. In the year 1995, what is the difference between the Exports(as % of merchandise exports) in Low & middle income and Exports(as % of merchandise exports) in Haiti?
Provide a succinct answer. -23.81. In the year 1995, what is the difference between the Exports(as % of merchandise exports) in Low & middle income and Exports(as % of merchandise exports) in Madagascar?
Your answer should be very brief. -55.46. In the year 1995, what is the difference between the Exports(as % of merchandise exports) of El Salvador and Exports(as % of merchandise exports) of Haiti?
Keep it short and to the point. 19.52. In the year 1995, what is the difference between the Exports(as % of merchandise exports) in El Salvador and Exports(as % of merchandise exports) in Madagascar?
Provide a succinct answer. -12.13. In the year 1995, what is the difference between the Exports(as % of merchandise exports) in Haiti and Exports(as % of merchandise exports) in Madagascar?
Ensure brevity in your answer.  -31.65. In the year 1996, what is the difference between the Exports(as % of merchandise exports) of Low & middle income and Exports(as % of merchandise exports) of El Salvador?
Keep it short and to the point. -38.97. In the year 1996, what is the difference between the Exports(as % of merchandise exports) of Low & middle income and Exports(as % of merchandise exports) of Haiti?
Your answer should be compact. -8.93. In the year 1996, what is the difference between the Exports(as % of merchandise exports) in Low & middle income and Exports(as % of merchandise exports) in Madagascar?
Ensure brevity in your answer.  -44.12. In the year 1996, what is the difference between the Exports(as % of merchandise exports) of El Salvador and Exports(as % of merchandise exports) of Haiti?
Your response must be concise. 30.05. In the year 1996, what is the difference between the Exports(as % of merchandise exports) in El Salvador and Exports(as % of merchandise exports) in Madagascar?
Ensure brevity in your answer.  -5.15. In the year 1996, what is the difference between the Exports(as % of merchandise exports) of Haiti and Exports(as % of merchandise exports) of Madagascar?
Offer a very short reply. -35.2. What is the ratio of the Exports(as % of merchandise exports) in Low & middle income in 1990 to that in 1991?
Offer a very short reply. 1.02. What is the ratio of the Exports(as % of merchandise exports) of El Salvador in 1990 to that in 1991?
Give a very brief answer. 1.03. What is the ratio of the Exports(as % of merchandise exports) in Haiti in 1990 to that in 1991?
Offer a very short reply. 0.95. What is the ratio of the Exports(as % of merchandise exports) in Madagascar in 1990 to that in 1991?
Make the answer very short. 1.1. What is the ratio of the Exports(as % of merchandise exports) in Low & middle income in 1990 to that in 1992?
Provide a short and direct response. 1.08. What is the ratio of the Exports(as % of merchandise exports) of El Salvador in 1990 to that in 1992?
Your answer should be compact. 1.19. What is the ratio of the Exports(as % of merchandise exports) of Haiti in 1990 to that in 1992?
Your answer should be compact. 0.84. What is the ratio of the Exports(as % of merchandise exports) in Madagascar in 1990 to that in 1992?
Provide a succinct answer. 1.07. What is the ratio of the Exports(as % of merchandise exports) in Low & middle income in 1990 to that in 1993?
Your answer should be compact. 1.12. What is the ratio of the Exports(as % of merchandise exports) in El Salvador in 1990 to that in 1993?
Offer a terse response. 1.14. What is the ratio of the Exports(as % of merchandise exports) in Haiti in 1990 to that in 1993?
Provide a succinct answer. 1.01. What is the ratio of the Exports(as % of merchandise exports) in Madagascar in 1990 to that in 1993?
Offer a very short reply. 1.1. What is the ratio of the Exports(as % of merchandise exports) of Low & middle income in 1990 to that in 1994?
Provide a short and direct response. 1.11. What is the ratio of the Exports(as % of merchandise exports) in Haiti in 1990 to that in 1994?
Provide a short and direct response. 0.57. What is the ratio of the Exports(as % of merchandise exports) in Madagascar in 1990 to that in 1994?
Your response must be concise. 0.93. What is the ratio of the Exports(as % of merchandise exports) of Low & middle income in 1990 to that in 1995?
Your answer should be very brief. 1.17. What is the ratio of the Exports(as % of merchandise exports) of El Salvador in 1990 to that in 1995?
Your answer should be compact. 1. What is the ratio of the Exports(as % of merchandise exports) of Haiti in 1990 to that in 1995?
Your answer should be very brief. 0.37. What is the ratio of the Exports(as % of merchandise exports) of Madagascar in 1990 to that in 1995?
Give a very brief answer. 1.05. What is the ratio of the Exports(as % of merchandise exports) in Low & middle income in 1990 to that in 1996?
Provide a short and direct response. 1.19. What is the ratio of the Exports(as % of merchandise exports) of El Salvador in 1990 to that in 1996?
Give a very brief answer. 1.09. What is the ratio of the Exports(as % of merchandise exports) in Haiti in 1990 to that in 1996?
Your response must be concise. 0.62. What is the ratio of the Exports(as % of merchandise exports) in Madagascar in 1990 to that in 1996?
Make the answer very short. 1.27. What is the ratio of the Exports(as % of merchandise exports) in Low & middle income in 1991 to that in 1992?
Make the answer very short. 1.05. What is the ratio of the Exports(as % of merchandise exports) of El Salvador in 1991 to that in 1992?
Ensure brevity in your answer.  1.15. What is the ratio of the Exports(as % of merchandise exports) in Haiti in 1991 to that in 1992?
Provide a succinct answer. 0.88. What is the ratio of the Exports(as % of merchandise exports) of Low & middle income in 1991 to that in 1993?
Give a very brief answer. 1.1. What is the ratio of the Exports(as % of merchandise exports) in El Salvador in 1991 to that in 1993?
Provide a short and direct response. 1.1. What is the ratio of the Exports(as % of merchandise exports) of Haiti in 1991 to that in 1993?
Your answer should be compact. 1.05. What is the ratio of the Exports(as % of merchandise exports) of Madagascar in 1991 to that in 1993?
Make the answer very short. 1. What is the ratio of the Exports(as % of merchandise exports) of Low & middle income in 1991 to that in 1994?
Offer a very short reply. 1.08. What is the ratio of the Exports(as % of merchandise exports) of El Salvador in 1991 to that in 1994?
Offer a very short reply. 1.09. What is the ratio of the Exports(as % of merchandise exports) of Haiti in 1991 to that in 1994?
Offer a terse response. 0.6. What is the ratio of the Exports(as % of merchandise exports) of Madagascar in 1991 to that in 1994?
Give a very brief answer. 0.85. What is the ratio of the Exports(as % of merchandise exports) of Low & middle income in 1991 to that in 1995?
Give a very brief answer. 1.14. What is the ratio of the Exports(as % of merchandise exports) in El Salvador in 1991 to that in 1995?
Give a very brief answer. 0.97. What is the ratio of the Exports(as % of merchandise exports) in Haiti in 1991 to that in 1995?
Your answer should be compact. 0.39. What is the ratio of the Exports(as % of merchandise exports) in Madagascar in 1991 to that in 1995?
Provide a short and direct response. 0.96. What is the ratio of the Exports(as % of merchandise exports) of Low & middle income in 1991 to that in 1996?
Your answer should be very brief. 1.17. What is the ratio of the Exports(as % of merchandise exports) in El Salvador in 1991 to that in 1996?
Your response must be concise. 1.06. What is the ratio of the Exports(as % of merchandise exports) in Haiti in 1991 to that in 1996?
Offer a terse response. 0.65. What is the ratio of the Exports(as % of merchandise exports) of Madagascar in 1991 to that in 1996?
Your response must be concise. 1.15. What is the ratio of the Exports(as % of merchandise exports) of Low & middle income in 1992 to that in 1993?
Offer a terse response. 1.04. What is the ratio of the Exports(as % of merchandise exports) of El Salvador in 1992 to that in 1993?
Give a very brief answer. 0.96. What is the ratio of the Exports(as % of merchandise exports) of Haiti in 1992 to that in 1993?
Your answer should be very brief. 1.2. What is the ratio of the Exports(as % of merchandise exports) of Madagascar in 1992 to that in 1993?
Keep it short and to the point. 1.03. What is the ratio of the Exports(as % of merchandise exports) in Low & middle income in 1992 to that in 1994?
Your answer should be compact. 1.03. What is the ratio of the Exports(as % of merchandise exports) of El Salvador in 1992 to that in 1994?
Your response must be concise. 0.95. What is the ratio of the Exports(as % of merchandise exports) of Haiti in 1992 to that in 1994?
Give a very brief answer. 0.68. What is the ratio of the Exports(as % of merchandise exports) in Madagascar in 1992 to that in 1994?
Your answer should be very brief. 0.87. What is the ratio of the Exports(as % of merchandise exports) of Low & middle income in 1992 to that in 1995?
Your answer should be very brief. 1.09. What is the ratio of the Exports(as % of merchandise exports) of El Salvador in 1992 to that in 1995?
Your answer should be very brief. 0.84. What is the ratio of the Exports(as % of merchandise exports) of Haiti in 1992 to that in 1995?
Your answer should be compact. 0.44. What is the ratio of the Exports(as % of merchandise exports) in Madagascar in 1992 to that in 1995?
Offer a terse response. 0.98. What is the ratio of the Exports(as % of merchandise exports) in Low & middle income in 1992 to that in 1996?
Ensure brevity in your answer.  1.11. What is the ratio of the Exports(as % of merchandise exports) of El Salvador in 1992 to that in 1996?
Provide a short and direct response. 0.92. What is the ratio of the Exports(as % of merchandise exports) of Haiti in 1992 to that in 1996?
Provide a succinct answer. 0.74. What is the ratio of the Exports(as % of merchandise exports) in Madagascar in 1992 to that in 1996?
Provide a succinct answer. 1.18. What is the ratio of the Exports(as % of merchandise exports) in Low & middle income in 1993 to that in 1994?
Make the answer very short. 0.99. What is the ratio of the Exports(as % of merchandise exports) in Haiti in 1993 to that in 1994?
Keep it short and to the point. 0.57. What is the ratio of the Exports(as % of merchandise exports) in Madagascar in 1993 to that in 1994?
Keep it short and to the point. 0.85. What is the ratio of the Exports(as % of merchandise exports) in Low & middle income in 1993 to that in 1995?
Your answer should be compact. 1.04. What is the ratio of the Exports(as % of merchandise exports) in El Salvador in 1993 to that in 1995?
Give a very brief answer. 0.88. What is the ratio of the Exports(as % of merchandise exports) of Haiti in 1993 to that in 1995?
Offer a very short reply. 0.37. What is the ratio of the Exports(as % of merchandise exports) in Madagascar in 1993 to that in 1995?
Your response must be concise. 0.96. What is the ratio of the Exports(as % of merchandise exports) of Low & middle income in 1993 to that in 1996?
Ensure brevity in your answer.  1.06. What is the ratio of the Exports(as % of merchandise exports) in El Salvador in 1993 to that in 1996?
Provide a short and direct response. 0.96. What is the ratio of the Exports(as % of merchandise exports) of Haiti in 1993 to that in 1996?
Ensure brevity in your answer.  0.62. What is the ratio of the Exports(as % of merchandise exports) of Madagascar in 1993 to that in 1996?
Offer a terse response. 1.15. What is the ratio of the Exports(as % of merchandise exports) in Low & middle income in 1994 to that in 1995?
Your answer should be very brief. 1.06. What is the ratio of the Exports(as % of merchandise exports) in El Salvador in 1994 to that in 1995?
Your answer should be compact. 0.89. What is the ratio of the Exports(as % of merchandise exports) in Haiti in 1994 to that in 1995?
Ensure brevity in your answer.  0.65. What is the ratio of the Exports(as % of merchandise exports) of Madagascar in 1994 to that in 1995?
Offer a very short reply. 1.13. What is the ratio of the Exports(as % of merchandise exports) in Low & middle income in 1994 to that in 1996?
Your response must be concise. 1.08. What is the ratio of the Exports(as % of merchandise exports) in El Salvador in 1994 to that in 1996?
Your answer should be compact. 0.97. What is the ratio of the Exports(as % of merchandise exports) in Haiti in 1994 to that in 1996?
Keep it short and to the point. 1.09. What is the ratio of the Exports(as % of merchandise exports) of Madagascar in 1994 to that in 1996?
Keep it short and to the point. 1.36. What is the ratio of the Exports(as % of merchandise exports) of Low & middle income in 1995 to that in 1996?
Provide a succinct answer. 1.02. What is the ratio of the Exports(as % of merchandise exports) of El Salvador in 1995 to that in 1996?
Make the answer very short. 1.09. What is the ratio of the Exports(as % of merchandise exports) in Haiti in 1995 to that in 1996?
Keep it short and to the point. 1.68. What is the ratio of the Exports(as % of merchandise exports) in Madagascar in 1995 to that in 1996?
Provide a succinct answer. 1.2. What is the difference between the highest and the second highest Exports(as % of merchandise exports) in Low & middle income?
Your answer should be compact. 0.39. What is the difference between the highest and the second highest Exports(as % of merchandise exports) of El Salvador?
Keep it short and to the point. 0.24. What is the difference between the highest and the second highest Exports(as % of merchandise exports) in Haiti?
Your response must be concise. 13.05. What is the difference between the highest and the second highest Exports(as % of merchandise exports) in Madagascar?
Your answer should be very brief. 5.32. What is the difference between the highest and the lowest Exports(as % of merchandise exports) in Low & middle income?
Provide a short and direct response. 2.61. What is the difference between the highest and the lowest Exports(as % of merchandise exports) of El Salvador?
Keep it short and to the point. 9.14. What is the difference between the highest and the lowest Exports(as % of merchandise exports) in Haiti?
Your answer should be very brief. 23.65. What is the difference between the highest and the lowest Exports(as % of merchandise exports) in Madagascar?
Your response must be concise. 20.59. 